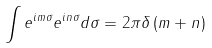<formula> <loc_0><loc_0><loc_500><loc_500>\int e ^ { i m \sigma } e ^ { i n \sigma } d \sigma = 2 \pi \delta \left ( m + n \right )</formula> 